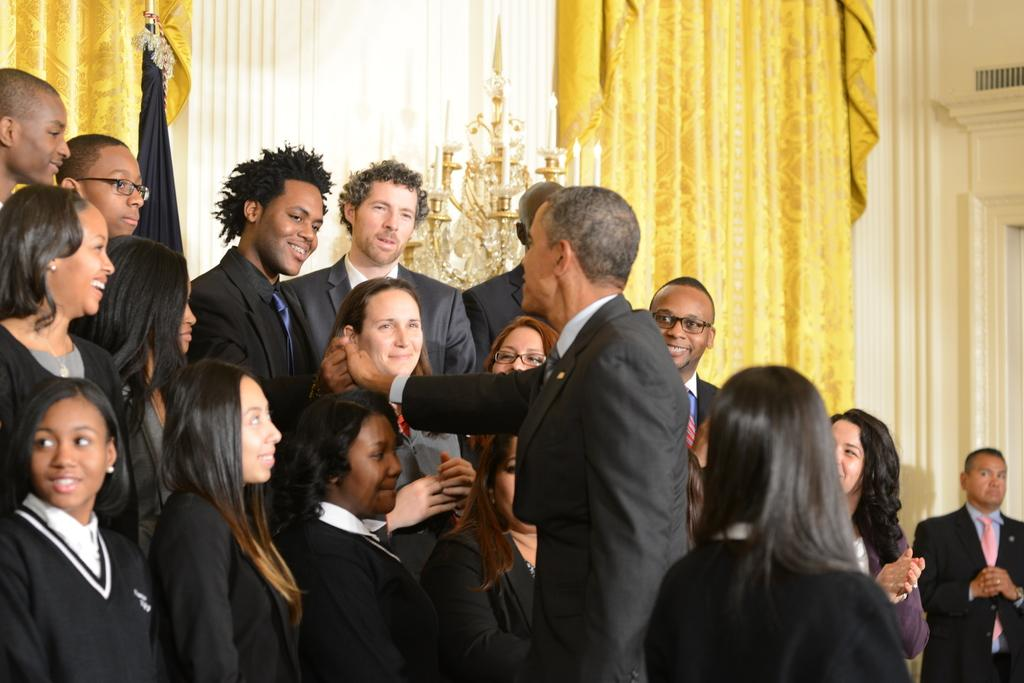Who or what can be seen in the image? There are people in the image. What is located behind the people? There is an object behind the people. What can be seen in the background of the image? There are curtains in the background of the image. What type of toy can be seen in the image? There is no toy present in the image. Are any cast members visible in the image? There is no reference to cast members or any performance in the image, so it is not possible to determine if any cast members are visible. 